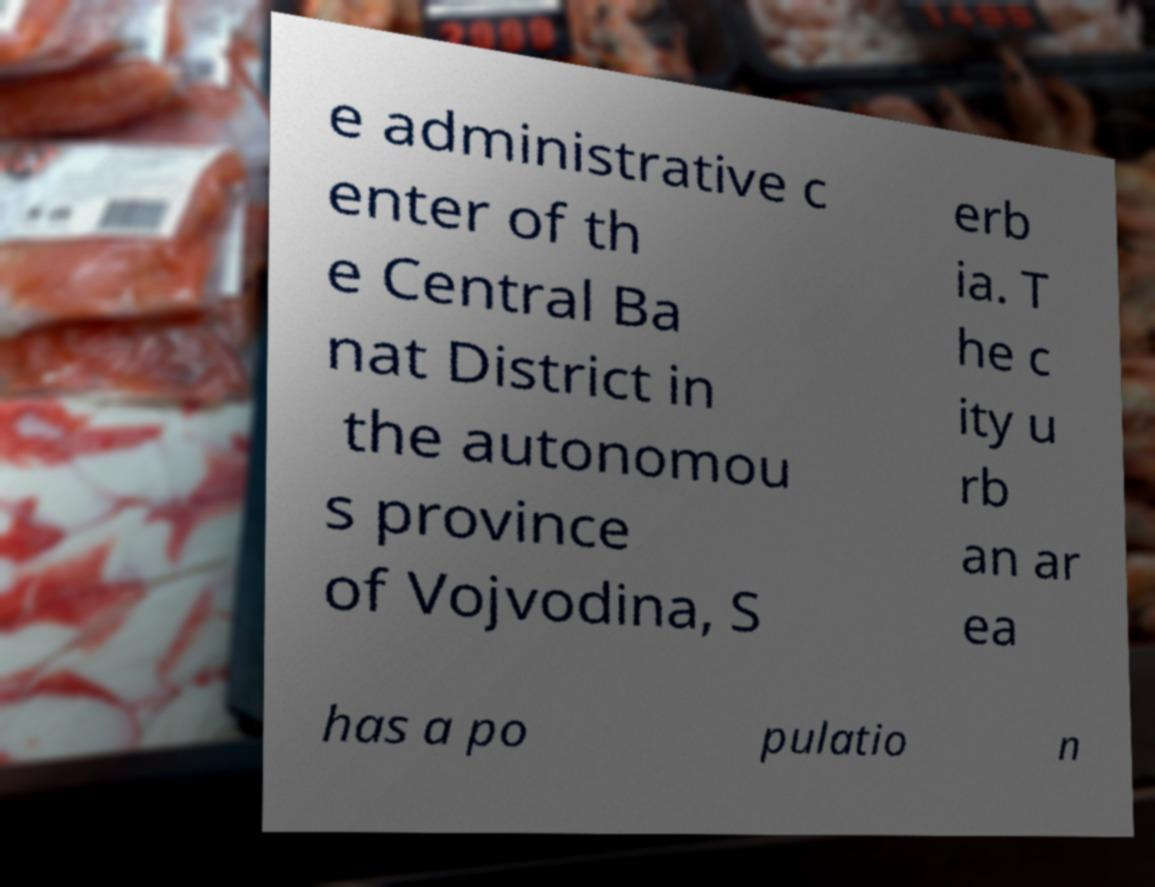There's text embedded in this image that I need extracted. Can you transcribe it verbatim? e administrative c enter of th e Central Ba nat District in the autonomou s province of Vojvodina, S erb ia. T he c ity u rb an ar ea has a po pulatio n 